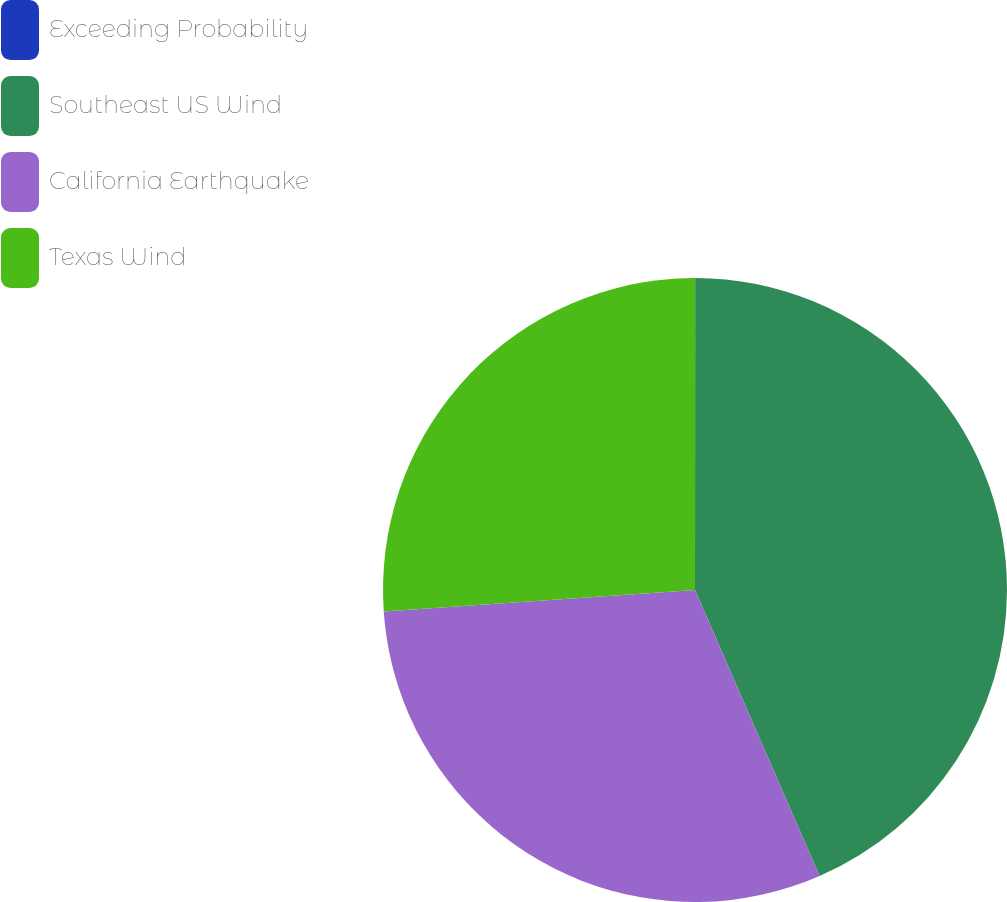Convert chart to OTSL. <chart><loc_0><loc_0><loc_500><loc_500><pie_chart><fcel>Exceeding Probability<fcel>Southeast US Wind<fcel>California Earthquake<fcel>Texas Wind<nl><fcel>0.01%<fcel>43.45%<fcel>30.44%<fcel>26.1%<nl></chart> 